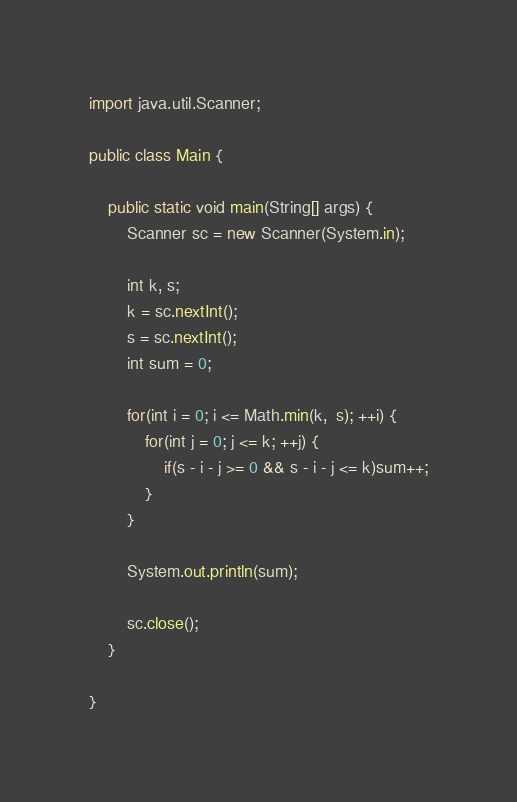<code> <loc_0><loc_0><loc_500><loc_500><_Java_>

import java.util.Scanner;

public class Main {

	public static void main(String[] args) {
		Scanner sc = new Scanner(System.in);
		
		int k, s;
		k = sc.nextInt();
		s = sc.nextInt();
		int sum = 0;
		
		for(int i = 0; i <= Math.min(k,  s); ++i) {
			for(int j = 0; j <= k; ++j) {
				if(s - i - j >= 0 && s - i - j <= k)sum++;
			}
		}
		
		System.out.println(sum);
		
		sc.close();
	}

}
</code> 